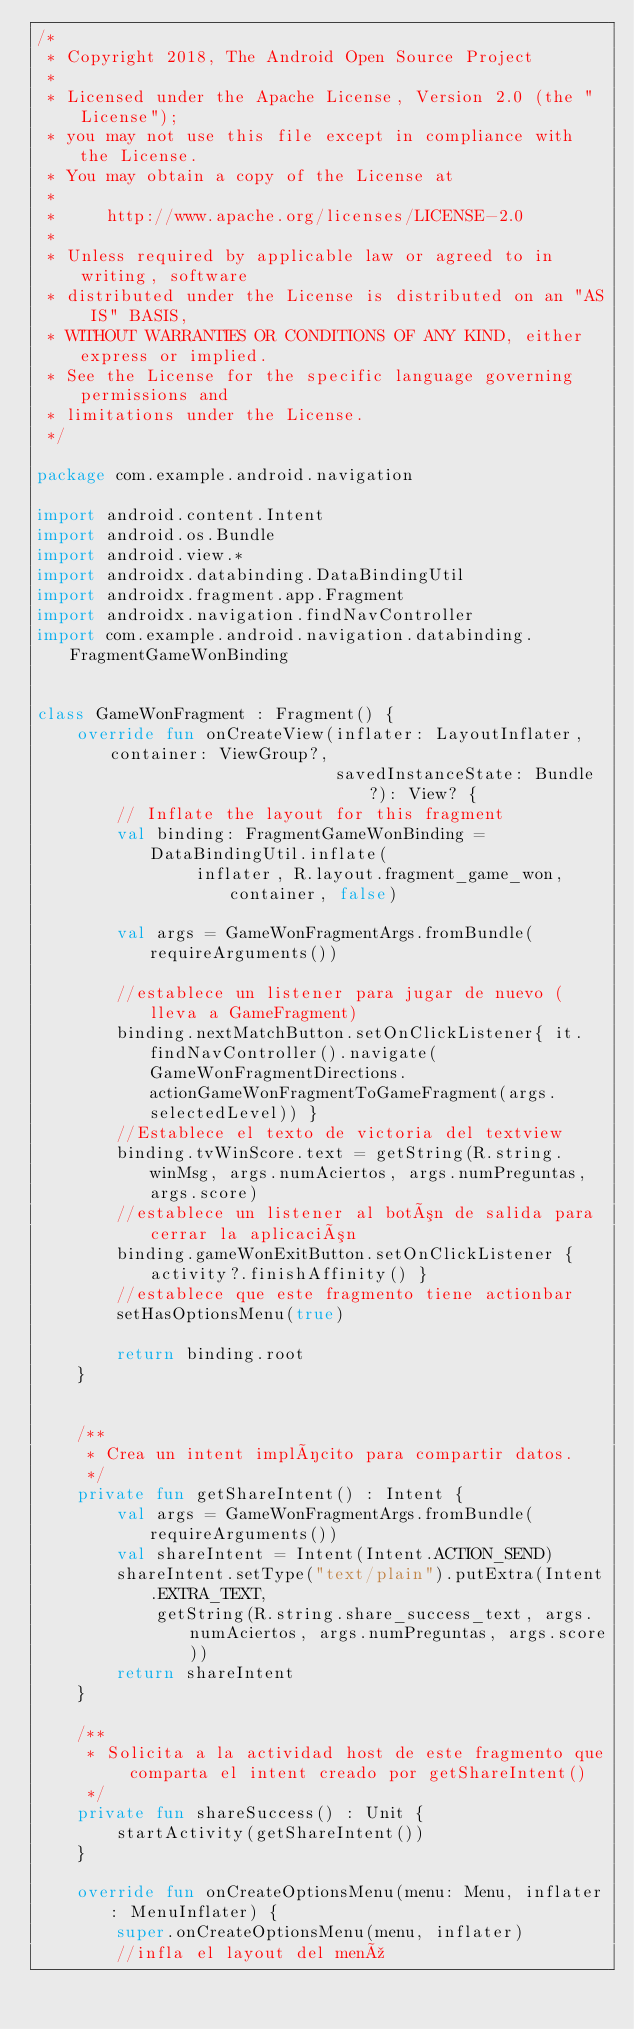<code> <loc_0><loc_0><loc_500><loc_500><_Kotlin_>/*
 * Copyright 2018, The Android Open Source Project
 *
 * Licensed under the Apache License, Version 2.0 (the "License");
 * you may not use this file except in compliance with the License.
 * You may obtain a copy of the License at
 *
 *     http://www.apache.org/licenses/LICENSE-2.0
 *
 * Unless required by applicable law or agreed to in writing, software
 * distributed under the License is distributed on an "AS IS" BASIS,
 * WITHOUT WARRANTIES OR CONDITIONS OF ANY KIND, either express or implied.
 * See the License for the specific language governing permissions and
 * limitations under the License.
 */

package com.example.android.navigation

import android.content.Intent
import android.os.Bundle
import android.view.*
import androidx.databinding.DataBindingUtil
import androidx.fragment.app.Fragment
import androidx.navigation.findNavController
import com.example.android.navigation.databinding.FragmentGameWonBinding


class GameWonFragment : Fragment() {
    override fun onCreateView(inflater: LayoutInflater, container: ViewGroup?,
                              savedInstanceState: Bundle?): View? {
        // Inflate the layout for this fragment
        val binding: FragmentGameWonBinding = DataBindingUtil.inflate(
                inflater, R.layout.fragment_game_won, container, false)

        val args = GameWonFragmentArgs.fromBundle(requireArguments())

        //establece un listener para jugar de nuevo (lleva a GameFragment)
        binding.nextMatchButton.setOnClickListener{ it.findNavController().navigate(GameWonFragmentDirections.actionGameWonFragmentToGameFragment(args.selectedLevel)) }
        //Establece el texto de victoria del textview
        binding.tvWinScore.text = getString(R.string.winMsg, args.numAciertos, args.numPreguntas, args.score)
        //establece un listener al botón de salida para cerrar la aplicación
        binding.gameWonExitButton.setOnClickListener { activity?.finishAffinity() }
        //establece que este fragmento tiene actionbar
        setHasOptionsMenu(true)

        return binding.root
    }


    /**
     * Crea un intent implícito para compartir datos.
     */
    private fun getShareIntent() : Intent {
        val args = GameWonFragmentArgs.fromBundle(requireArguments())
        val shareIntent = Intent(Intent.ACTION_SEND)
        shareIntent.setType("text/plain").putExtra(Intent.EXTRA_TEXT,
            getString(R.string.share_success_text, args.numAciertos, args.numPreguntas, args.score))
        return shareIntent
    }

    /**
     * Solicita a la actividad host de este fragmento que comparta el intent creado por getShareIntent()
     */
    private fun shareSuccess() : Unit {
        startActivity(getShareIntent())
    }

    override fun onCreateOptionsMenu(menu: Menu, inflater: MenuInflater) {
        super.onCreateOptionsMenu(menu, inflater)
        //infla el layout del menú</code> 